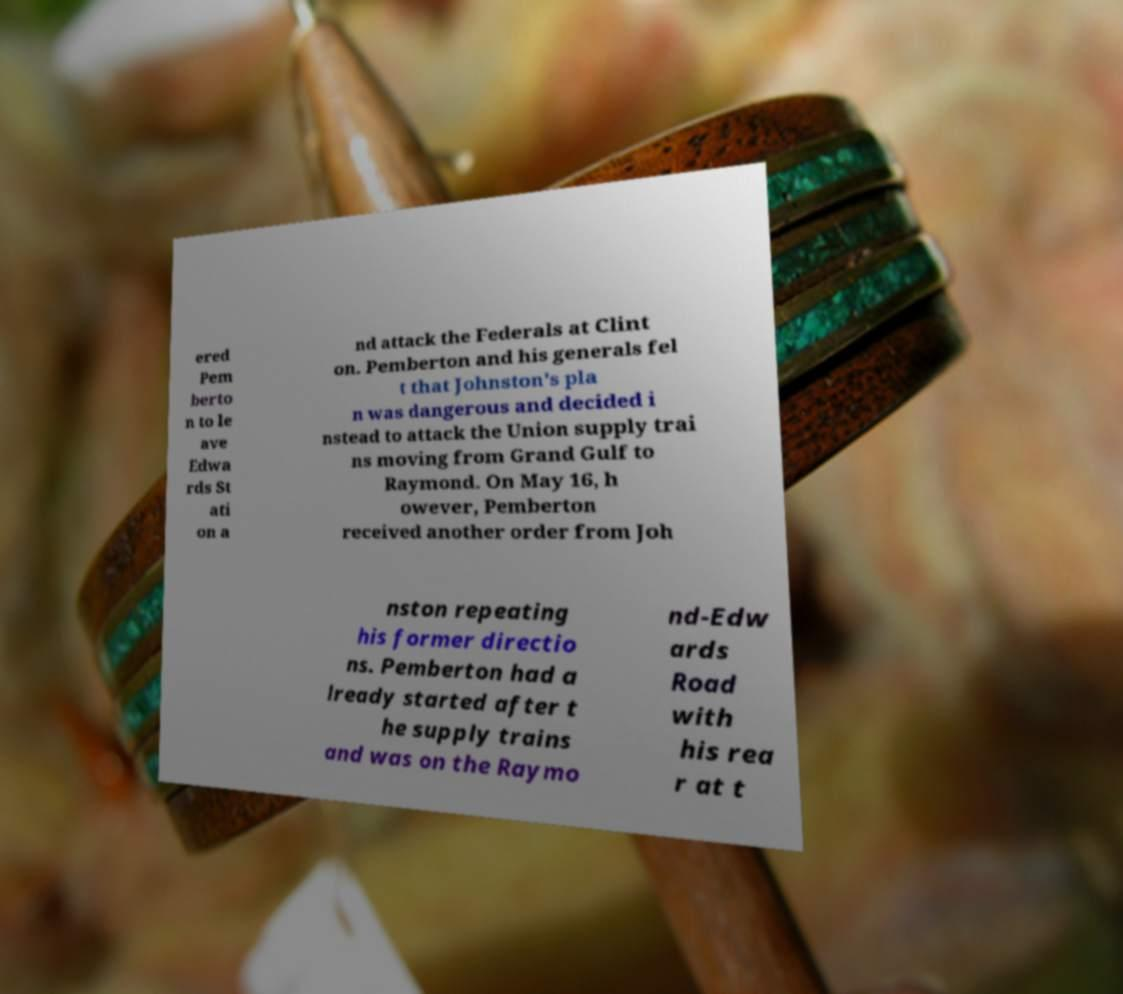I need the written content from this picture converted into text. Can you do that? ered Pem berto n to le ave Edwa rds St ati on a nd attack the Federals at Clint on. Pemberton and his generals fel t that Johnston's pla n was dangerous and decided i nstead to attack the Union supply trai ns moving from Grand Gulf to Raymond. On May 16, h owever, Pemberton received another order from Joh nston repeating his former directio ns. Pemberton had a lready started after t he supply trains and was on the Raymo nd-Edw ards Road with his rea r at t 